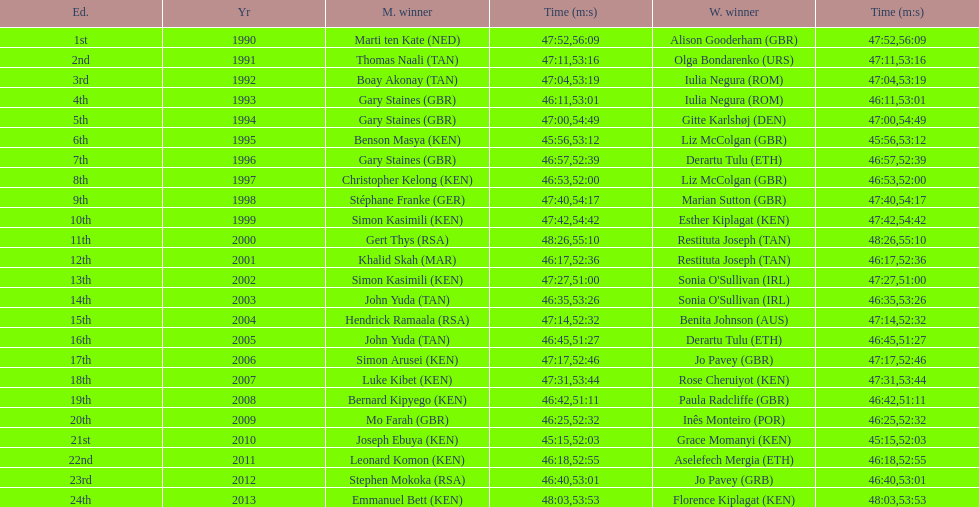Where any women faster than any men? No. 